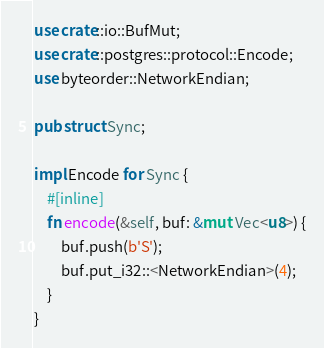<code> <loc_0><loc_0><loc_500><loc_500><_Rust_>use crate::io::BufMut;
use crate::postgres::protocol::Encode;
use byteorder::NetworkEndian;

pub struct Sync;

impl Encode for Sync {
    #[inline]
    fn encode(&self, buf: &mut Vec<u8>) {
        buf.push(b'S');
        buf.put_i32::<NetworkEndian>(4);
    }
}
</code> 